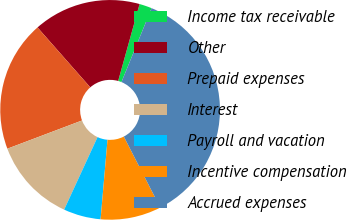<chart> <loc_0><loc_0><loc_500><loc_500><pie_chart><fcel>Income tax receivable<fcel>Other<fcel>Prepaid expenses<fcel>Interest<fcel>Payroll and vacation<fcel>Incentive compensation<fcel>Accrued expenses<nl><fcel>1.84%<fcel>15.82%<fcel>19.26%<fcel>12.38%<fcel>5.49%<fcel>8.93%<fcel>36.29%<nl></chart> 